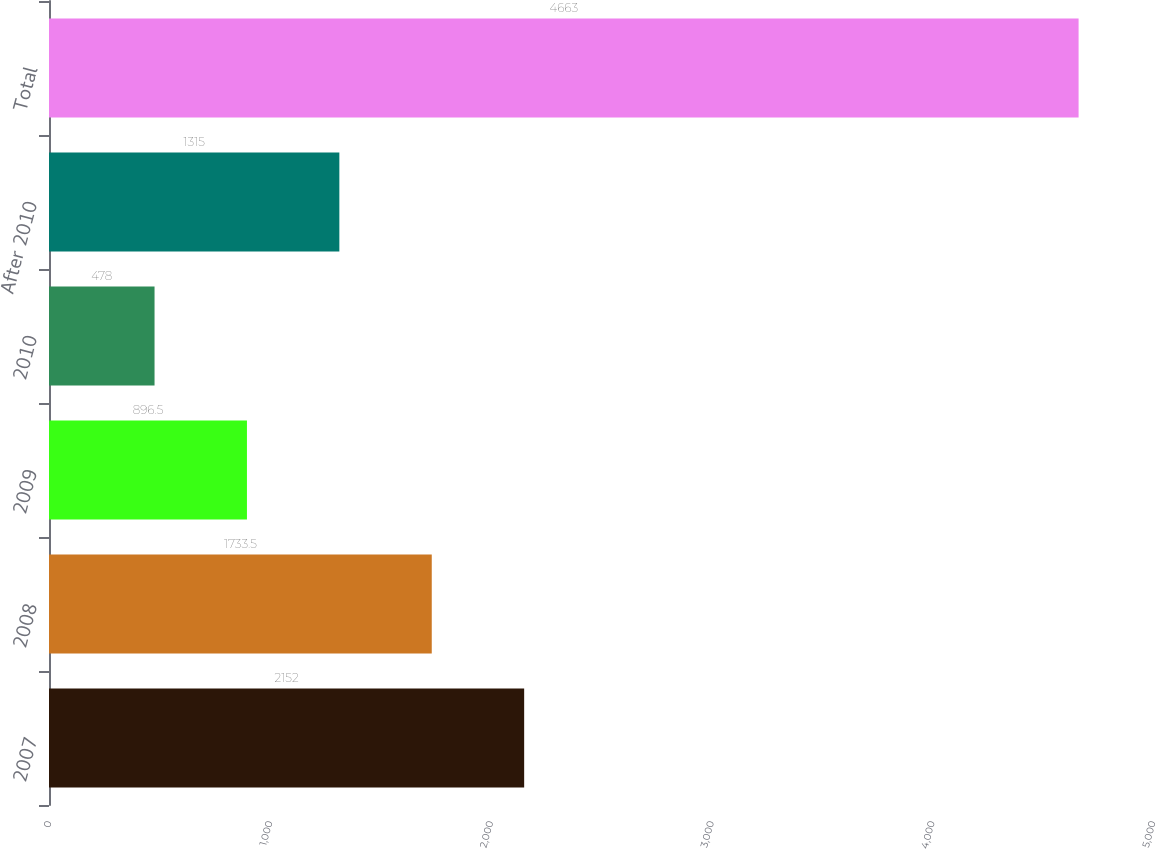Convert chart to OTSL. <chart><loc_0><loc_0><loc_500><loc_500><bar_chart><fcel>2007<fcel>2008<fcel>2009<fcel>2010<fcel>After 2010<fcel>Total<nl><fcel>2152<fcel>1733.5<fcel>896.5<fcel>478<fcel>1315<fcel>4663<nl></chart> 